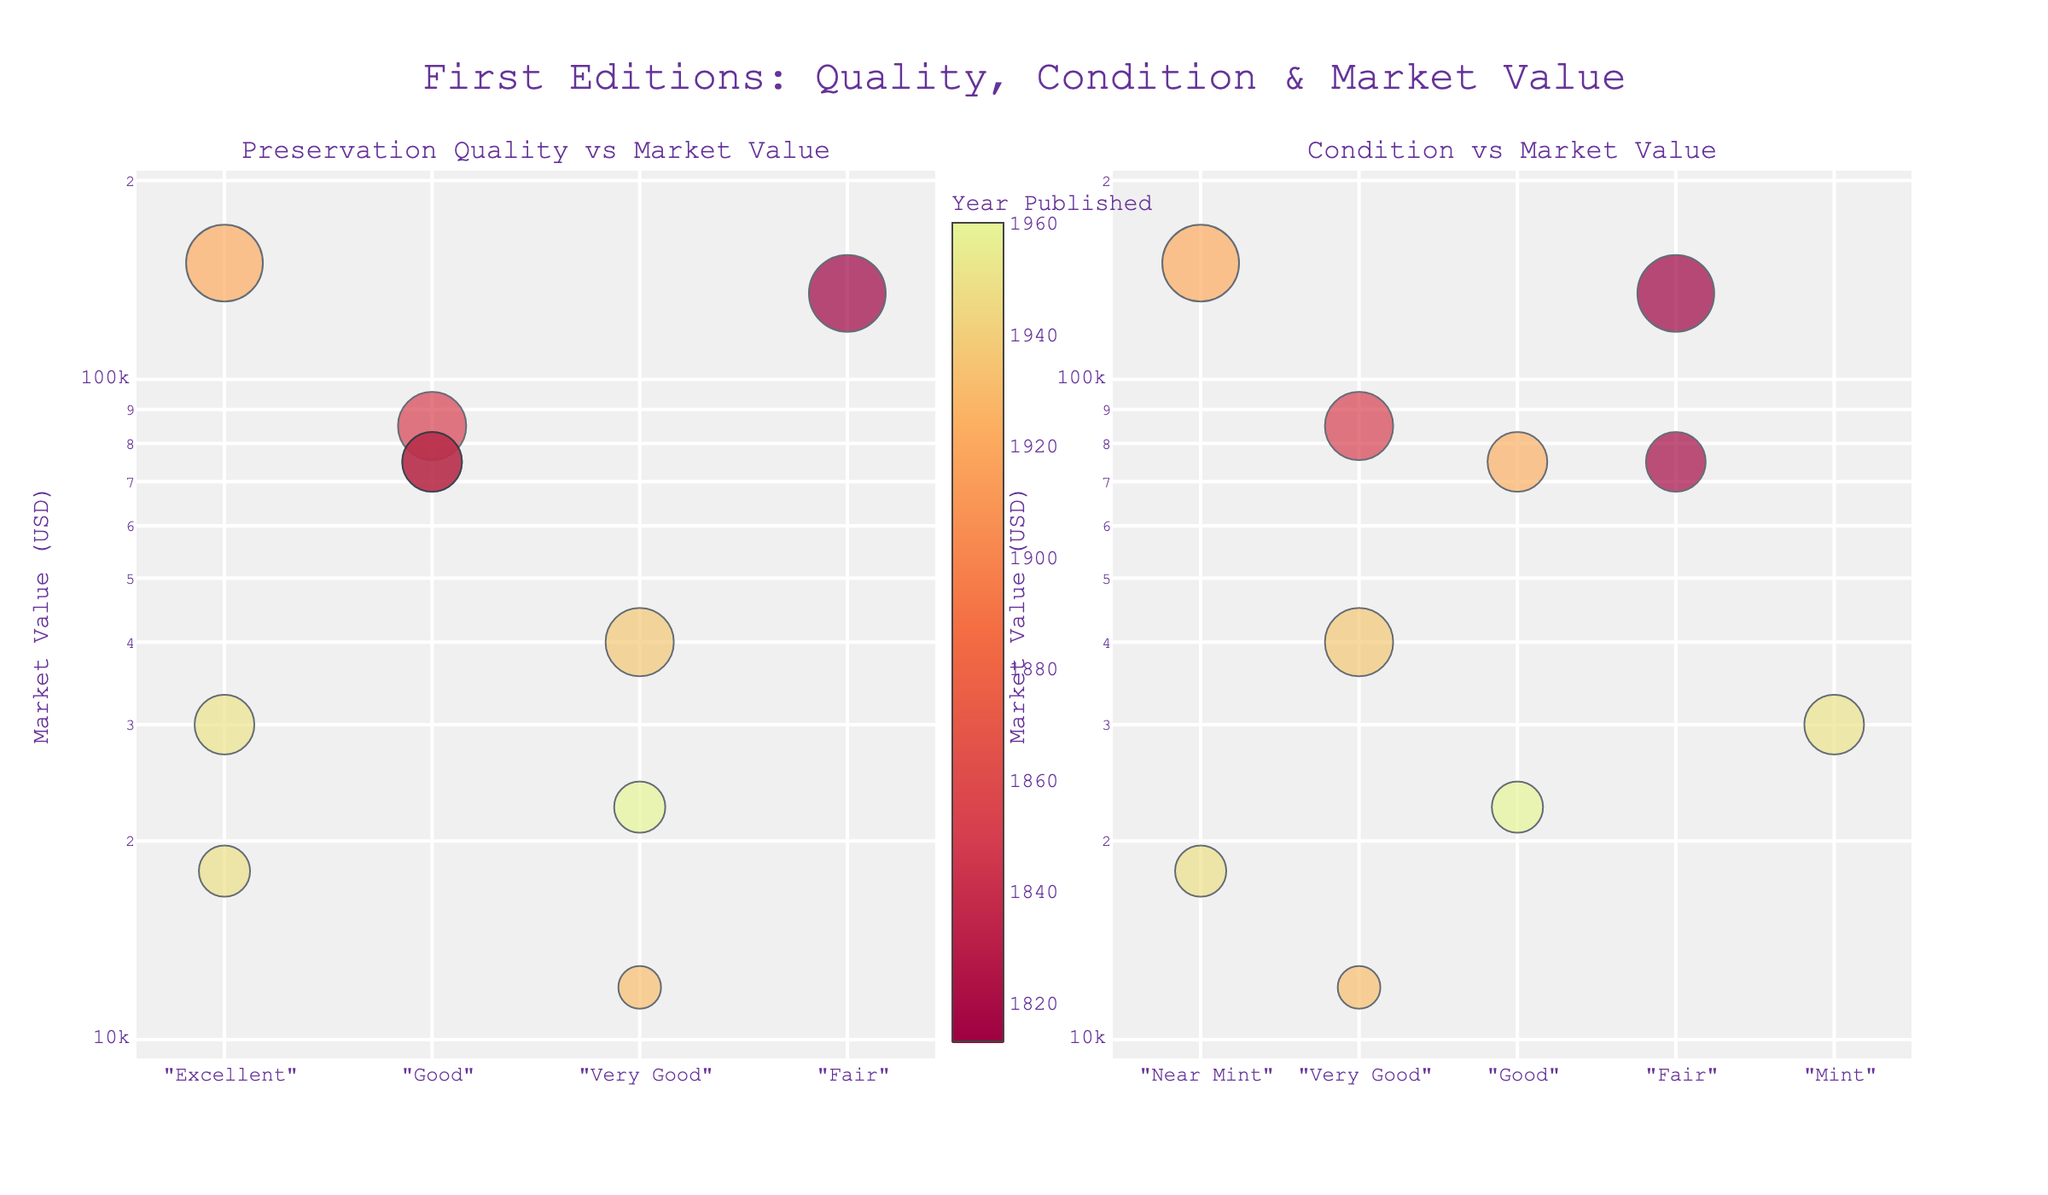Which book has the highest market value in near mint condition? We look at the subplot titled "Condition vs Market Value" and find the highest y-axis value among the points labeled "Near Mint." Hovering over the points reveals the highest market value for near mint is associated with "Ulysses."
Answer: Ulysses How does the market value compare between books published before 1900 and those published after 1900? We look at the years of publication in each subplot and compare the market values. Older books (before 1900) like "Moby-Dick" and "Pride and Prejudice" generally have higher market values compared to newer editions.
Answer: Older books generally have higher market values What is the market value of "The Great Gatsby" in good condition? In the "Condition vs Market Value" subplot, hover over the point labeled "Good" for "The Great Gatsby." The y-axis value at this point tells us the market value for this book.
Answer: $75,000 Which book has the highest rarity score and what is its market value? Checking the sizes of the bubbles (indicative of rarity score) in either subplot, we observe that "Ulysses" has the largest bubble. Hovering over this point gives us its market value.
Answer: Ulysses, $150,000 Are there any books with a condition rated as "Mint," and what is their market value? We look at the "Condition vs Market Value" subplot and find the bubbles labeled "Mint." "The Catcher in the Rye" is shown to have a value around $30,000.
Answer: The Catcher in the Rye, $30,000 How does market value vary with preservation quality? We observe the "Preservation Quality vs Market Value" subplot. Generally, as we move from "Fair" to "Excellent," the trend shows that market value increases.
Answer: Higher preservation quality correlates with higher market value Which book was published the earliest and what is its condition and market value? On either subplot, we find the bubble colored with the value for the earliest year, which is "Pride and Prejudice" from 1813. Its condition is "Fair" and market value is around $135,000.
Answer: Pride and Prejudice, Fair, $135,000 How do the preservation qualities of "Near Mint" and "Mint" influence the market values? We observe "Preservation Quality vs Market Value" subplot, comparing "Near Mint" and "Mint" bubbles. "Mint" has fewer data points but a consistent high value. "Near Mint" has more variety, including some high market values.
Answer: Both are high, Mint has consistent high values What is the relationship between rarity score and bubble size in the charts? Bubble size in both subplots directly corresponds to the rarity score, with larger bubbles indicating higher rarity scores.
Answer: Larger bubbles have higher rarity scores 